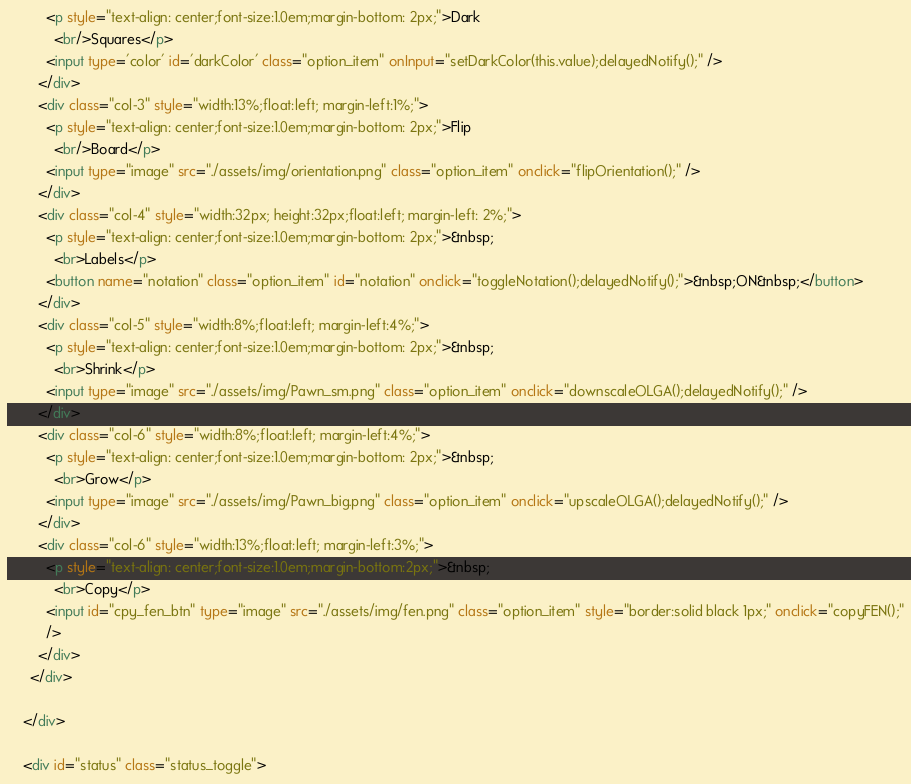<code> <loc_0><loc_0><loc_500><loc_500><_HTML_>          <p style="text-align: center;font-size:1.0em;margin-bottom: 2px;">Dark
            <br/>Squares</p>
          <input type='color' id='darkColor' class="option_item" onInput="setDarkColor(this.value);delayedNotify();" />
        </div>
        <div class="col-3" style="width:13%;float:left; margin-left:1%;">
          <p style="text-align: center;font-size:1.0em;margin-bottom: 2px;">Flip
            <br/>Board</p>
          <input type="image" src="./assets/img/orientation.png" class="option_item" onclick="flipOrientation();" />
        </div>
        <div class="col-4" style="width:32px; height:32px;float:left; margin-left: 2%;">
          <p style="text-align: center;font-size:1.0em;margin-bottom: 2px;">&nbsp;
            <br>Labels</p>
          <button name="notation" class="option_item" id="notation" onclick="toggleNotation();delayedNotify();">&nbsp;ON&nbsp;</button>
        </div>
        <div class="col-5" style="width:8%;float:left; margin-left:4%;">
          <p style="text-align: center;font-size:1.0em;margin-bottom: 2px;">&nbsp;
            <br>Shrink</p>
          <input type="image" src="./assets/img/Pawn_sm.png" class="option_item" onclick="downscaleOLGA();delayedNotify();" />
        </div>
        <div class="col-6" style="width:8%;float:left; margin-left:4%;">
          <p style="text-align: center;font-size:1.0em;margin-bottom: 2px;">&nbsp;
            <br>Grow</p>
          <input type="image" src="./assets/img/Pawn_big.png" class="option_item" onclick="upscaleOLGA();delayedNotify();" />
        </div>
        <div class="col-6" style="width:13%;float:left; margin-left:3%;">
          <p style="text-align: center;font-size:1.0em;margin-bottom:2px;">&nbsp;
            <br>Copy</p>
          <input id="cpy_fen_btn" type="image" src="./assets/img/fen.png" class="option_item" style="border:solid black 1px;" onclick="copyFEN();"
          />
        </div>
      </div>

    </div>

    <div id="status" class="status_toggle"></code> 